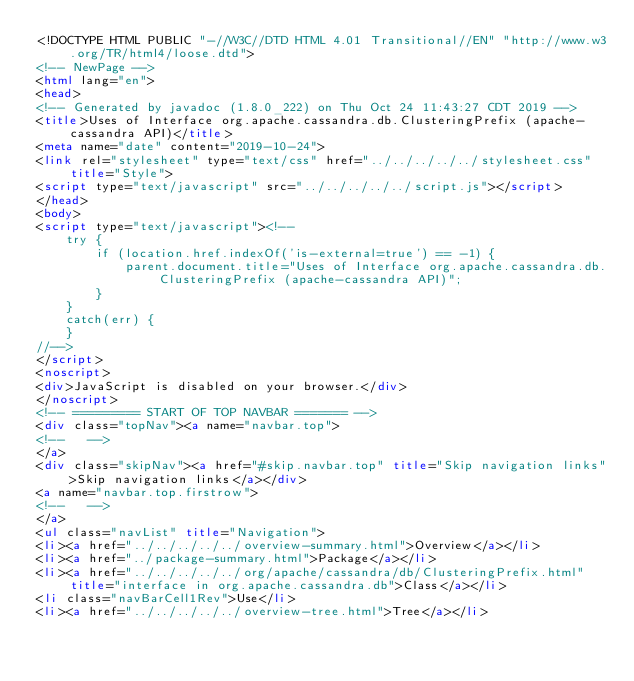<code> <loc_0><loc_0><loc_500><loc_500><_HTML_><!DOCTYPE HTML PUBLIC "-//W3C//DTD HTML 4.01 Transitional//EN" "http://www.w3.org/TR/html4/loose.dtd">
<!-- NewPage -->
<html lang="en">
<head>
<!-- Generated by javadoc (1.8.0_222) on Thu Oct 24 11:43:27 CDT 2019 -->
<title>Uses of Interface org.apache.cassandra.db.ClusteringPrefix (apache-cassandra API)</title>
<meta name="date" content="2019-10-24">
<link rel="stylesheet" type="text/css" href="../../../../../stylesheet.css" title="Style">
<script type="text/javascript" src="../../../../../script.js"></script>
</head>
<body>
<script type="text/javascript"><!--
    try {
        if (location.href.indexOf('is-external=true') == -1) {
            parent.document.title="Uses of Interface org.apache.cassandra.db.ClusteringPrefix (apache-cassandra API)";
        }
    }
    catch(err) {
    }
//-->
</script>
<noscript>
<div>JavaScript is disabled on your browser.</div>
</noscript>
<!-- ========= START OF TOP NAVBAR ======= -->
<div class="topNav"><a name="navbar.top">
<!--   -->
</a>
<div class="skipNav"><a href="#skip.navbar.top" title="Skip navigation links">Skip navigation links</a></div>
<a name="navbar.top.firstrow">
<!--   -->
</a>
<ul class="navList" title="Navigation">
<li><a href="../../../../../overview-summary.html">Overview</a></li>
<li><a href="../package-summary.html">Package</a></li>
<li><a href="../../../../../org/apache/cassandra/db/ClusteringPrefix.html" title="interface in org.apache.cassandra.db">Class</a></li>
<li class="navBarCell1Rev">Use</li>
<li><a href="../../../../../overview-tree.html">Tree</a></li></code> 